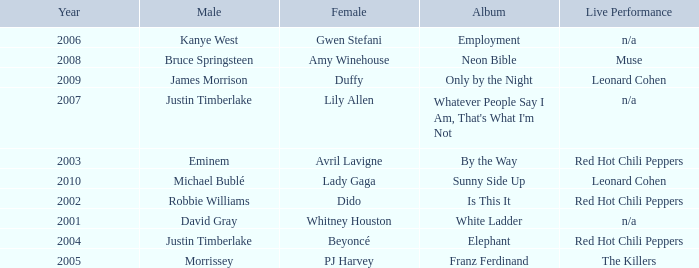Which female artist has an album named elephant? Beyoncé. 